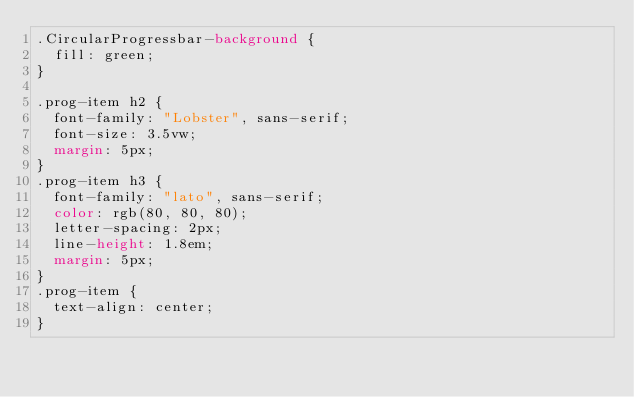Convert code to text. <code><loc_0><loc_0><loc_500><loc_500><_CSS_>.CircularProgressbar-background {
  fill: green;
}

.prog-item h2 {
  font-family: "Lobster", sans-serif;
  font-size: 3.5vw;
  margin: 5px;
}
.prog-item h3 {
  font-family: "lato", sans-serif;
  color: rgb(80, 80, 80);
  letter-spacing: 2px;
  line-height: 1.8em;
  margin: 5px;
}
.prog-item {
  text-align: center;
}
</code> 